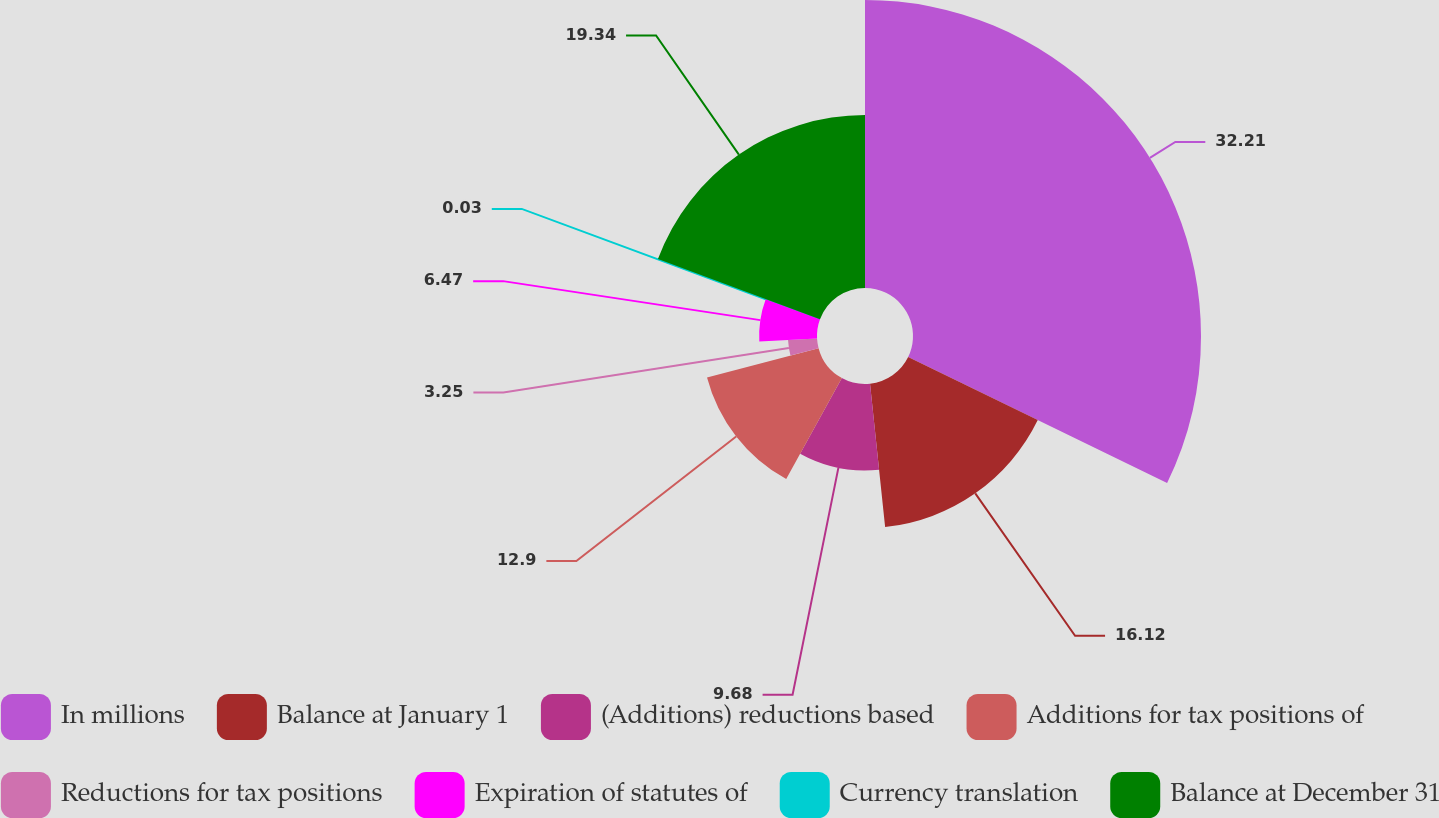Convert chart to OTSL. <chart><loc_0><loc_0><loc_500><loc_500><pie_chart><fcel>In millions<fcel>Balance at January 1<fcel>(Additions) reductions based<fcel>Additions for tax positions of<fcel>Reductions for tax positions<fcel>Expiration of statutes of<fcel>Currency translation<fcel>Balance at December 31<nl><fcel>32.21%<fcel>16.12%<fcel>9.68%<fcel>12.9%<fcel>3.25%<fcel>6.47%<fcel>0.03%<fcel>19.34%<nl></chart> 